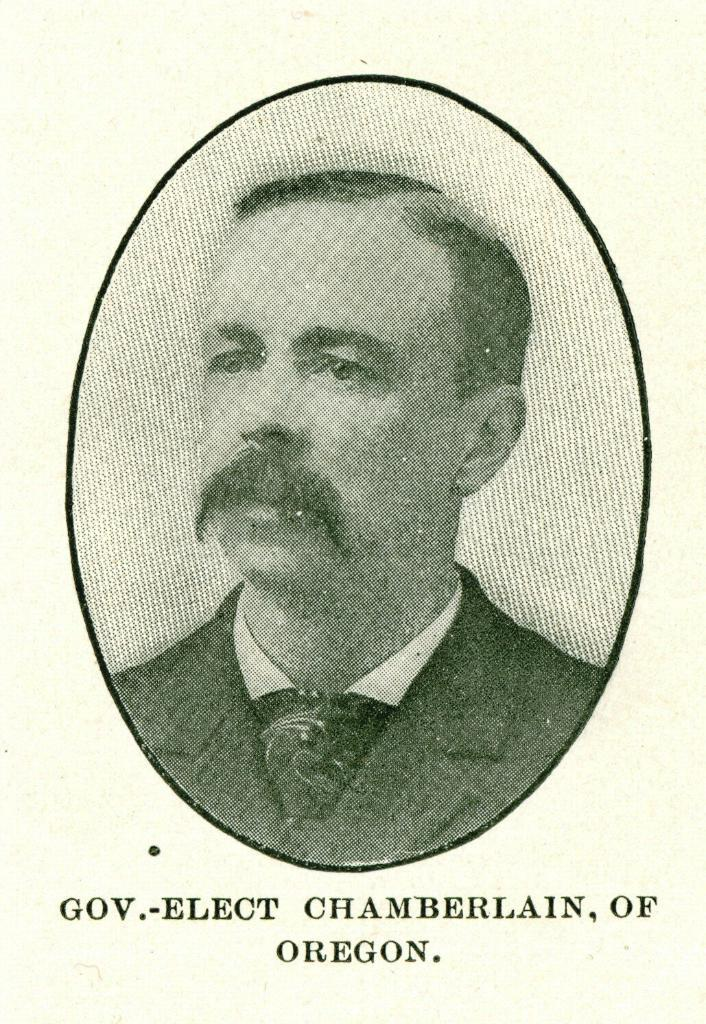What is the main subject of the image? There is a photograph in the image. Who is depicted in the photograph? The photograph is of a man. What is the man wearing in the image? The man is wearing a blazer and a tie. How much wealth does the man in the photograph possess? There is no information about the man's wealth in the image, so it cannot be determined. What news is the man in the photograph reporting? There is no indication that the man in the photograph is a news reporter or reporting any news. 